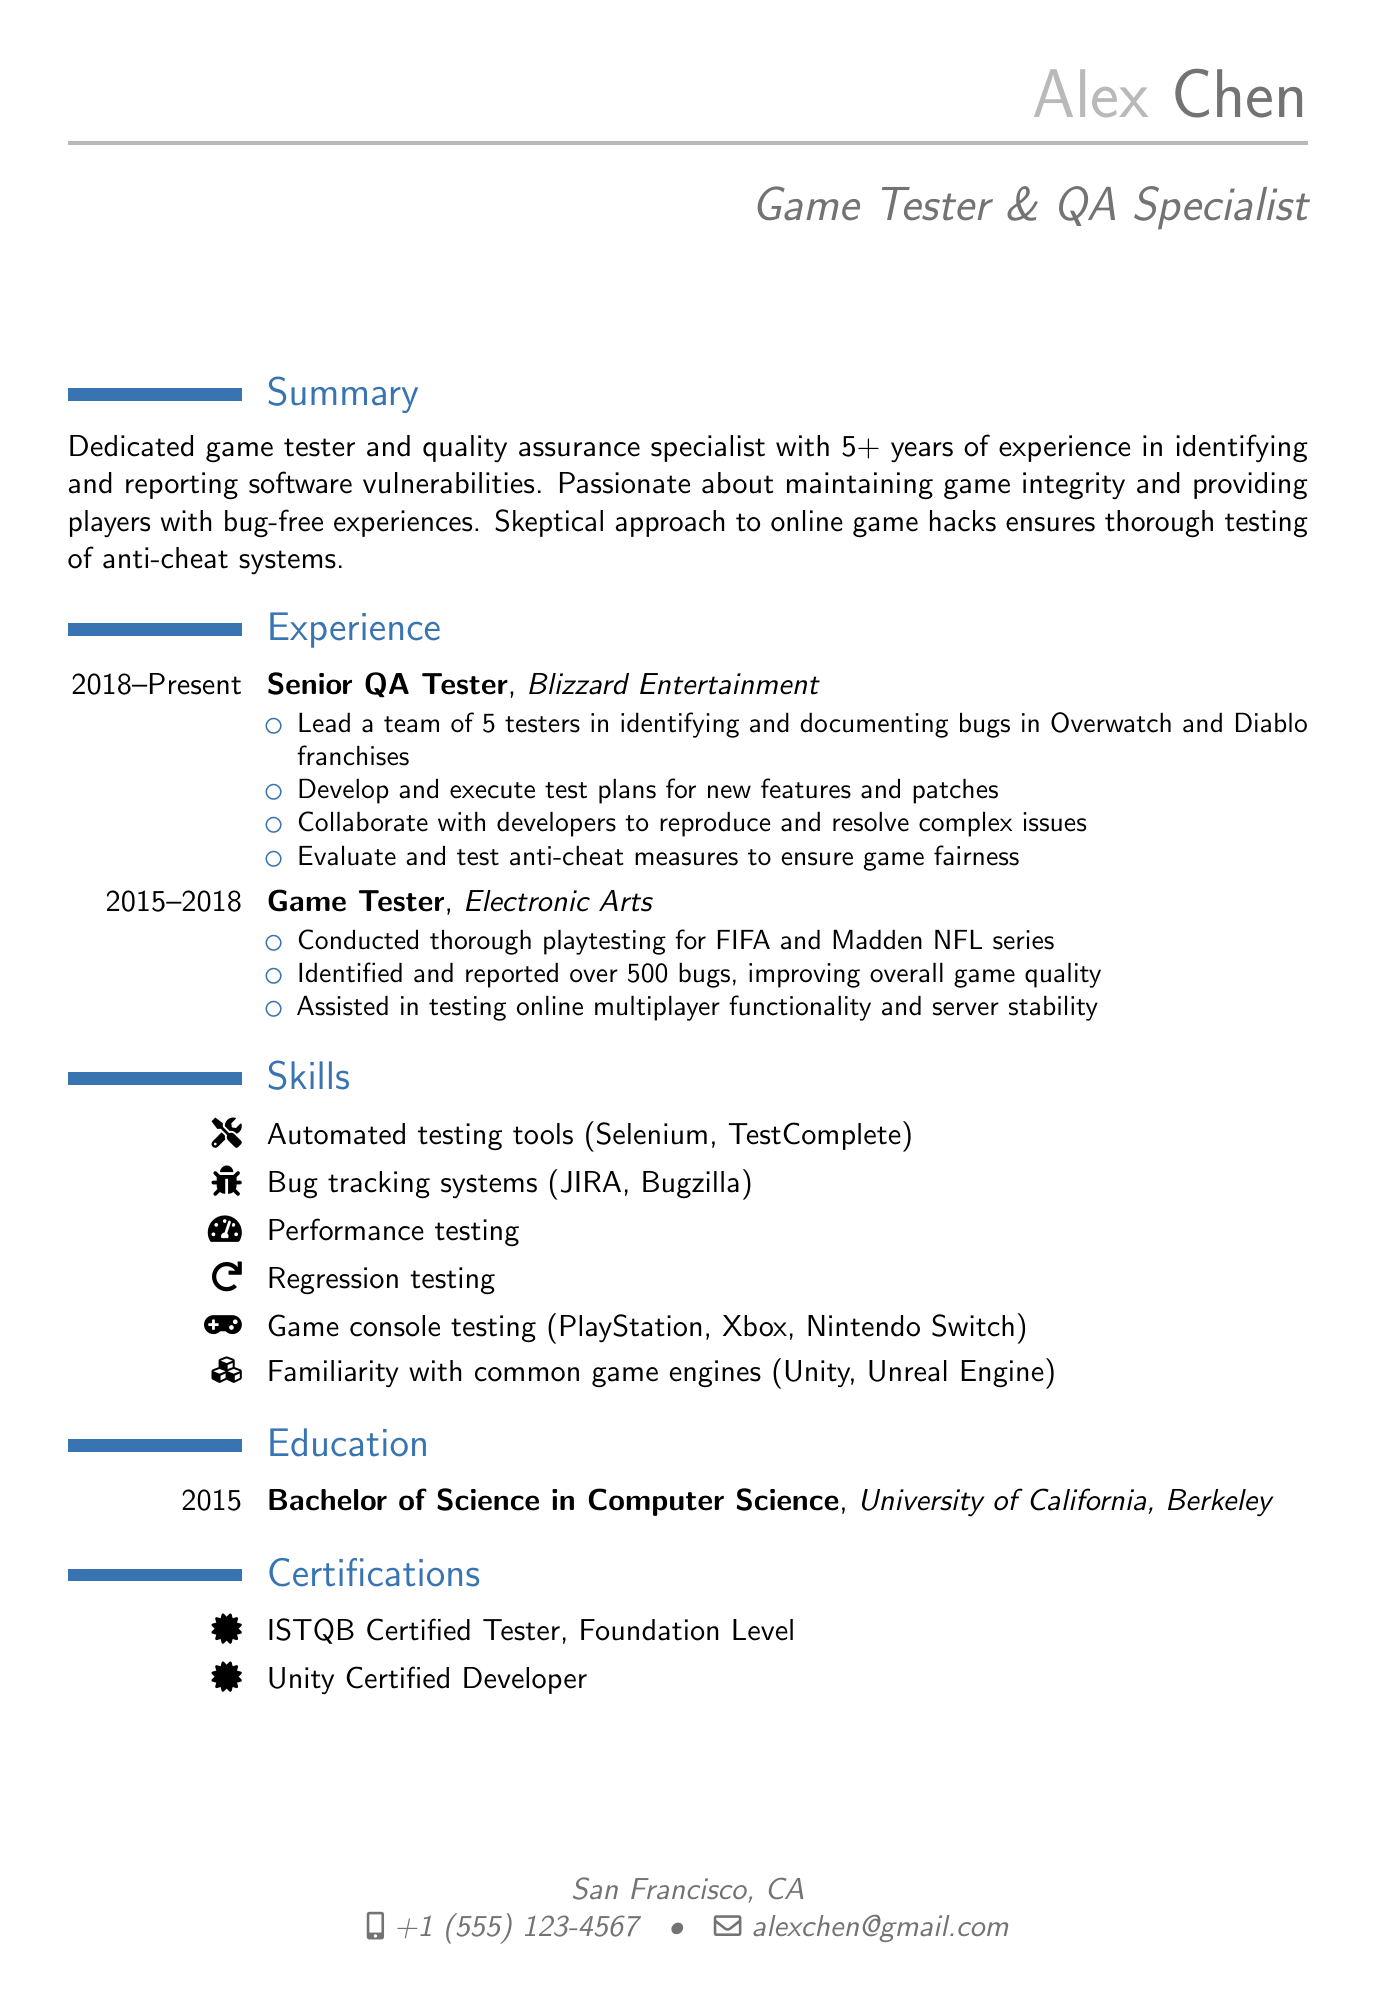what is the name of the candidate? The candidate's name is provided in the personal information section of the document.
Answer: Alex Chen what is the role of Alex Chen? The role listed in the document reflects the candidate's professional title.
Answer: Game Tester & QA Specialist how many years of experience does Alex Chen have? The summary section states the total years of experience in the field clearly.
Answer: 5+ which company does Alex Chen currently work for? The work experience section lists the current employer in the relevant entry.
Answer: Blizzard Entertainment how many bugs did Alex Chen identify while working at Electronic Arts? The responsibilities in the work experience section indicate the number of bugs reported.
Answer: over 500 bugs what certification does Alex Chen hold? The certifications section highlights the formal recognitions achieved by the candidate.
Answer: ISTQB Certified Tester, Foundation Level which game franchises did Alex Chen lead testing for? The responsibilities listed mention the specific game franchises in the current role.
Answer: Overwatch and Diablo in which year did Alex Chen graduate? The education section specifies the completion year of the academic degree earned.
Answer: 2015 what skill involves testing online multiplayer functionality? The skills section outlines various expertise areas applicable to the candidate's roles.
Answer: Game console testing 